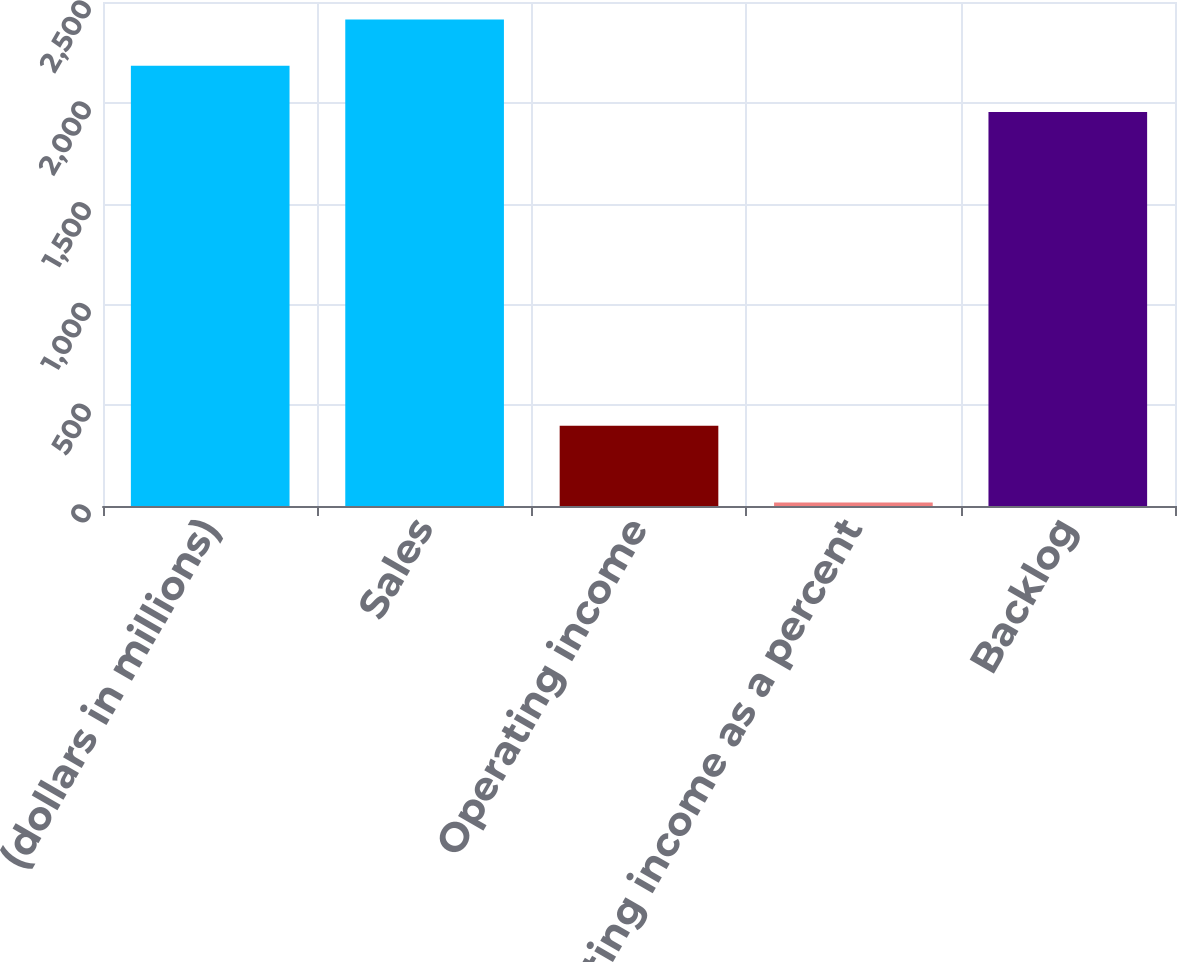Convert chart. <chart><loc_0><loc_0><loc_500><loc_500><bar_chart><fcel>(dollars in millions)<fcel>Sales<fcel>Operating income<fcel>Operating income as a percent<fcel>Backlog<nl><fcel>2183.88<fcel>2413.76<fcel>398<fcel>17.2<fcel>1954<nl></chart> 